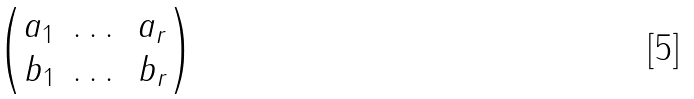<formula> <loc_0><loc_0><loc_500><loc_500>\begin{pmatrix} a _ { 1 } & \dots & a _ { r } \\ b _ { 1 } & \dots & b _ { r } \end{pmatrix}</formula> 